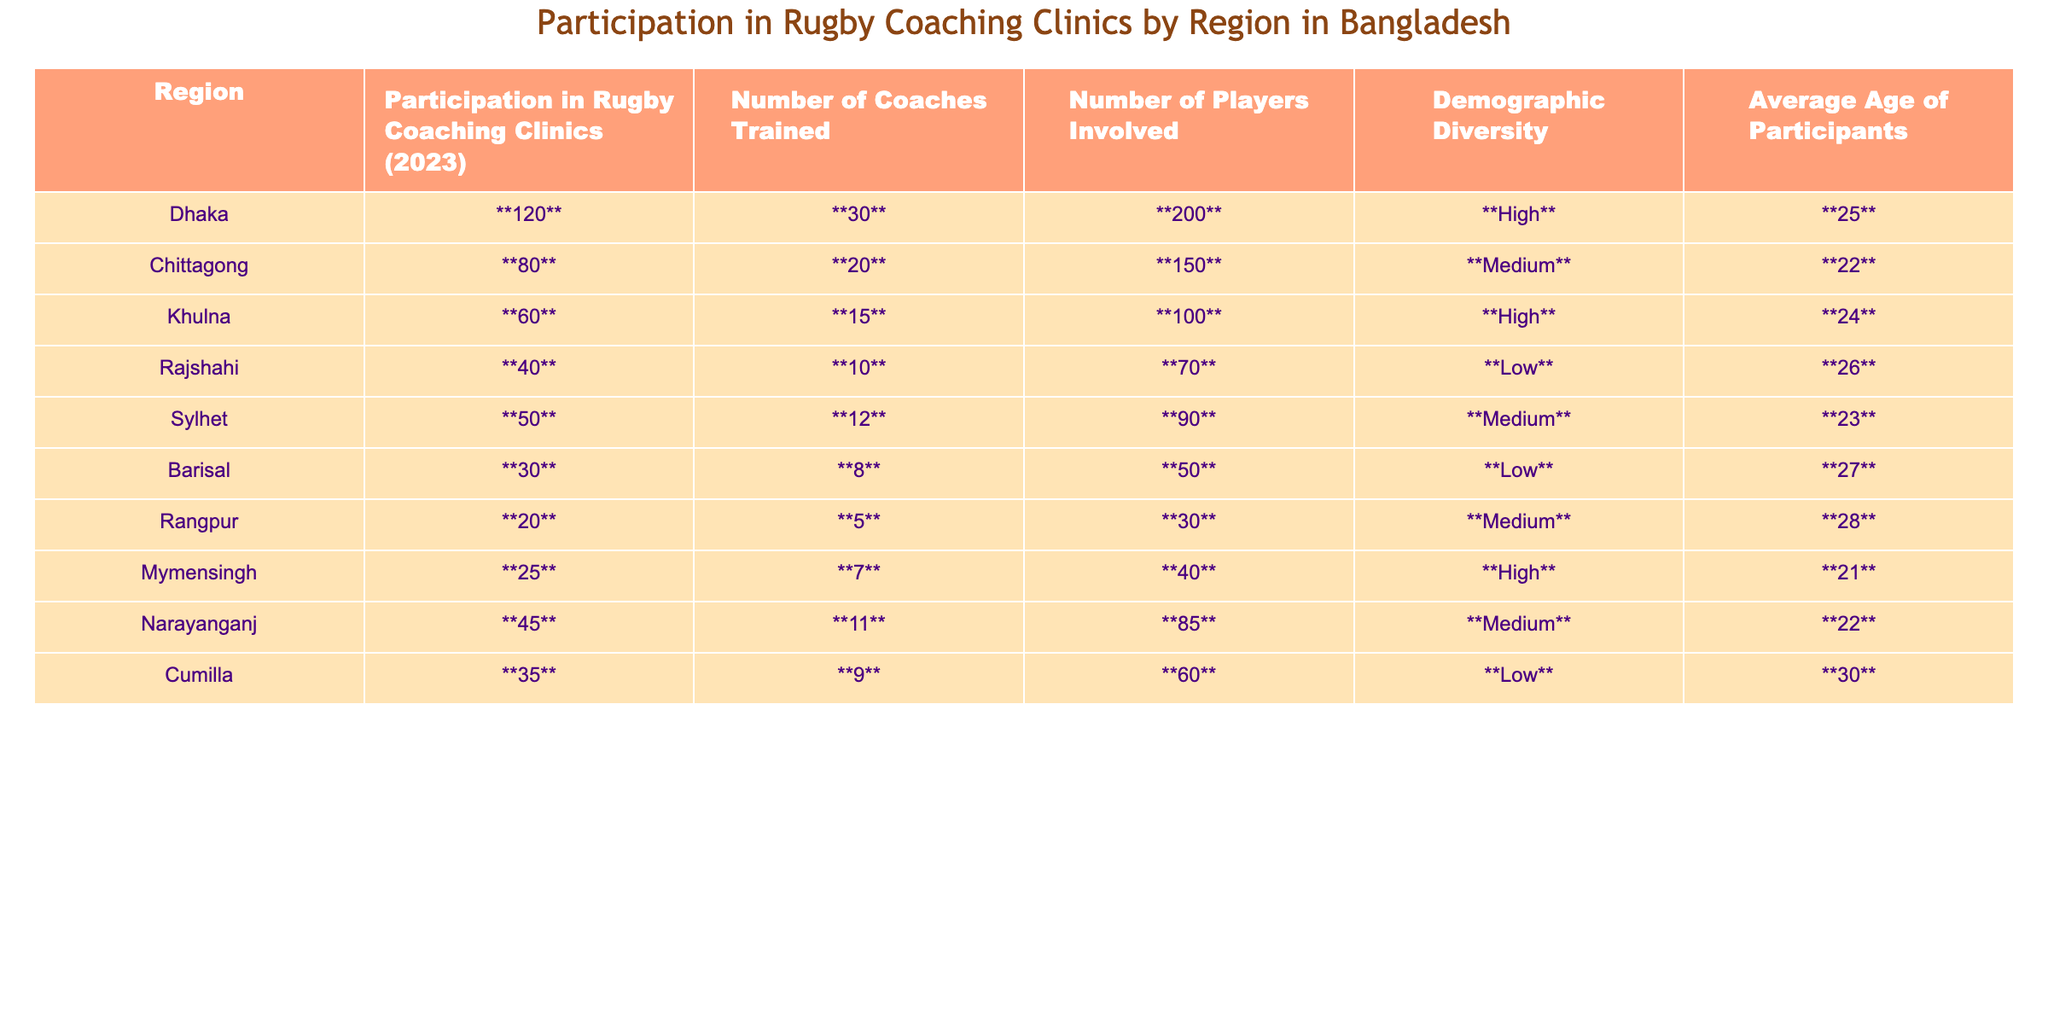What region had the highest participation in rugby coaching clinics? The highest participation is in Dhaka, where 120 participants attended.
Answer: Dhaka What is the average age of participants in Chittagong? According to the table, the average age of participants in Chittagong is 22 years old.
Answer: 22 How many coaches were trained in the Rajshahi region? The number of coaches trained in Rajshahi is 10.
Answer: 10 Which region had the least number of players involved? Rangpur had the least number of players involved with a total of 30 players.
Answer: Rangpur What is the total number of coaches trained across all regions? Summing all the coaches trained: 30 + 20 + 15 + 10 + 12 + 8 + 5 + 7 + 11 + 9 =  127 coaches were trained.
Answer: 127 Is there a region where the average age of participants is above 27? Yes, the regions of Rajshahi (26) and Barisal (27) do not have average ages above 27, while Rangpur has an average age of 28 which is above 27.
Answer: Yes Which region has medium demographic diversity and the highest number of players involved? Narayanganj has medium demographic diversity with the highest number of players involved at 85.
Answer: Narayanganj What is the difference in participation between Dhaka and Khulna? The participation in Dhaka is 120 and in Khulna is 60, so the difference is 120 - 60 = 60.
Answer: 60 Which region has the lowest number of participants and a low demographic diversity rating? Barisal has the lowest number of participants at 30 and a low demographic diversity rating.
Answer: Barisal How many regions had high demographic diversity? There are three regions with high demographic diversity: Dhaka, Khulna, and Mymensingh.
Answer: 3 What is the average number of players involved across all regions? To find the average, sum the players: 200 + 150 + 100 + 70 + 90 + 50 + 30 + 40 + 85 + 60 =  925, and divide by 10 = 92.5.
Answer: 92.5 